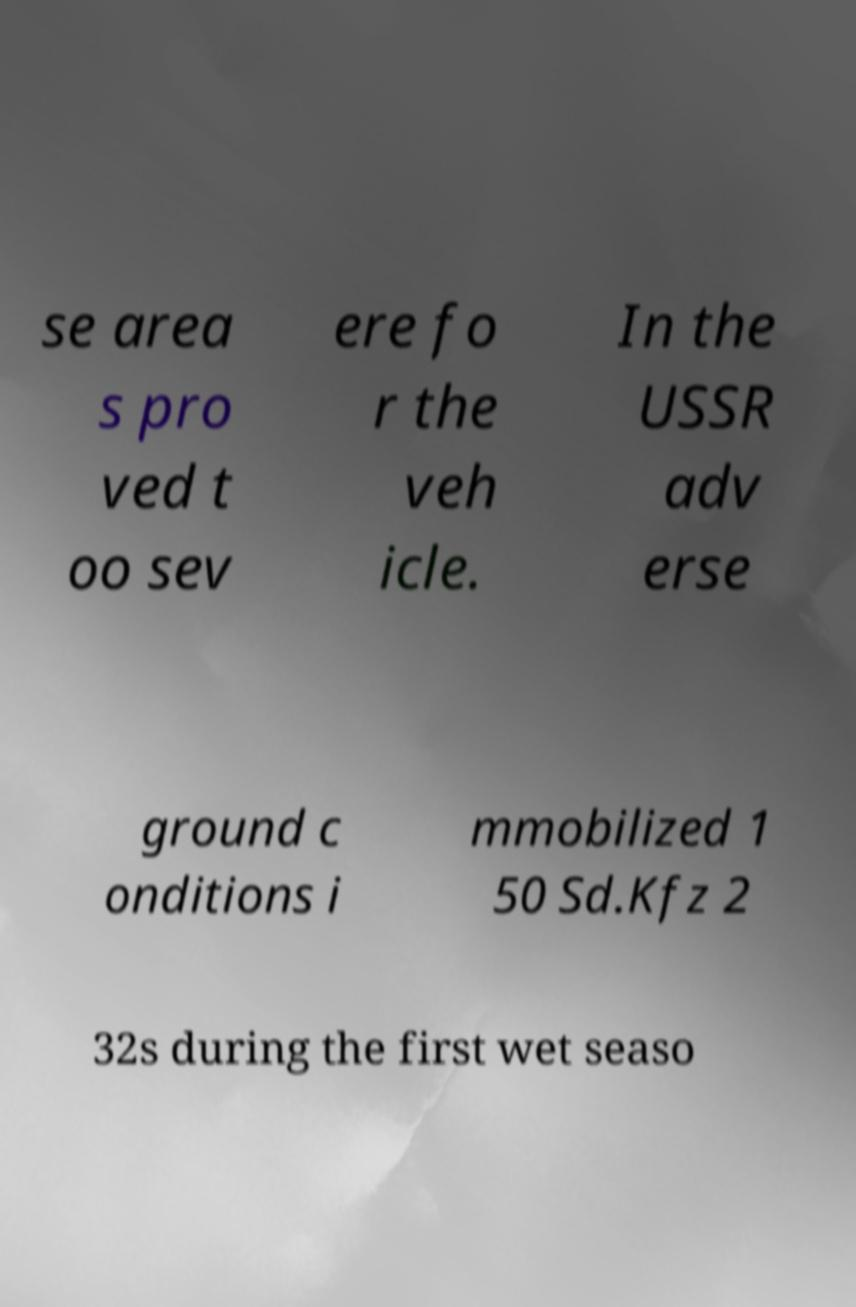Could you assist in decoding the text presented in this image and type it out clearly? se area s pro ved t oo sev ere fo r the veh icle. In the USSR adv erse ground c onditions i mmobilized 1 50 Sd.Kfz 2 32s during the first wet seaso 